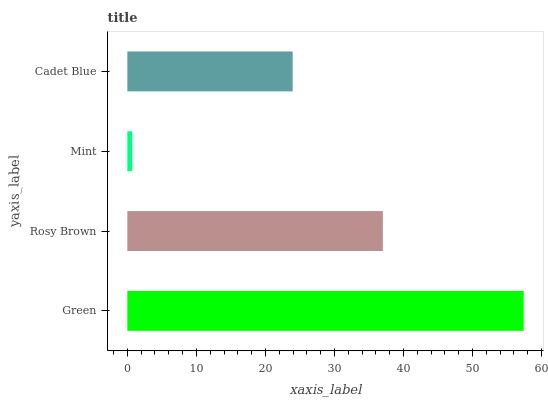Is Mint the minimum?
Answer yes or no. Yes. Is Green the maximum?
Answer yes or no. Yes. Is Rosy Brown the minimum?
Answer yes or no. No. Is Rosy Brown the maximum?
Answer yes or no. No. Is Green greater than Rosy Brown?
Answer yes or no. Yes. Is Rosy Brown less than Green?
Answer yes or no. Yes. Is Rosy Brown greater than Green?
Answer yes or no. No. Is Green less than Rosy Brown?
Answer yes or no. No. Is Rosy Brown the high median?
Answer yes or no. Yes. Is Cadet Blue the low median?
Answer yes or no. Yes. Is Cadet Blue the high median?
Answer yes or no. No. Is Mint the low median?
Answer yes or no. No. 